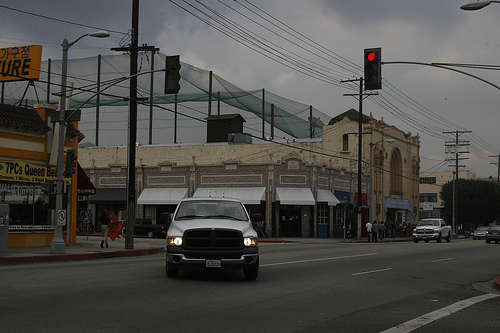<image>
Is there a shade behind the car? Yes. From this viewpoint, the shade is positioned behind the car, with the car partially or fully occluding the shade. 